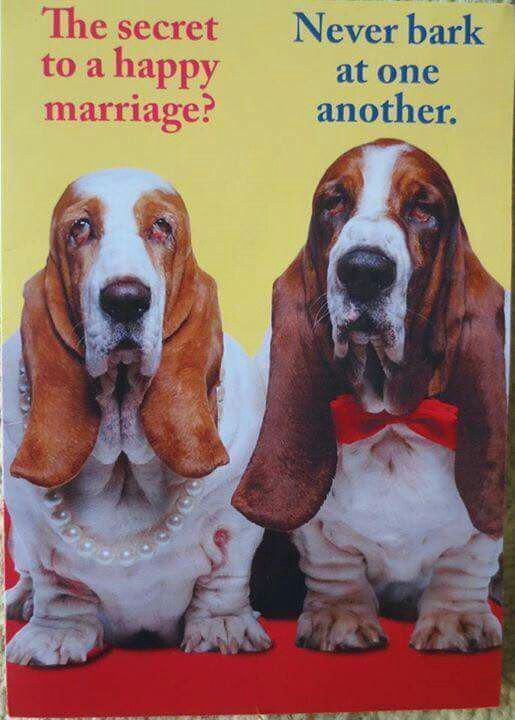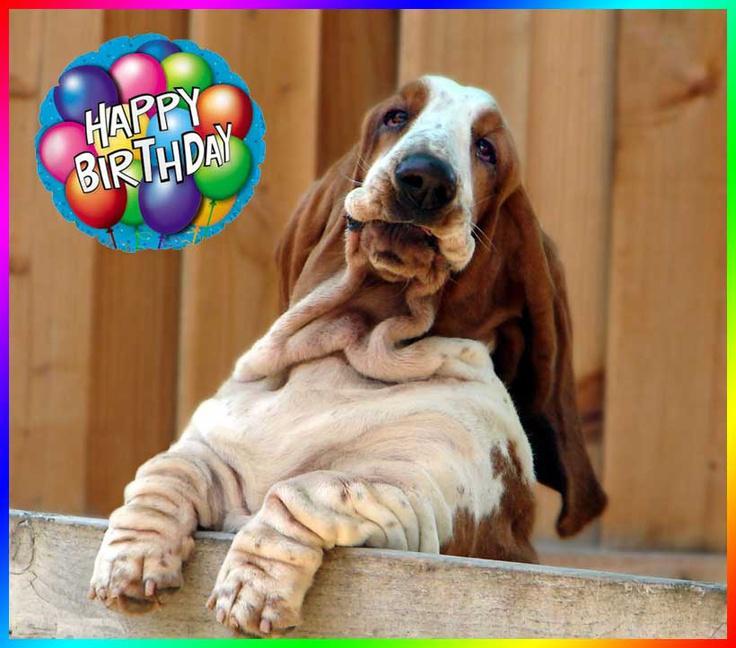The first image is the image on the left, the second image is the image on the right. Assess this claim about the two images: "One of the dogs is wearing a birthday hat.". Correct or not? Answer yes or no. No. 